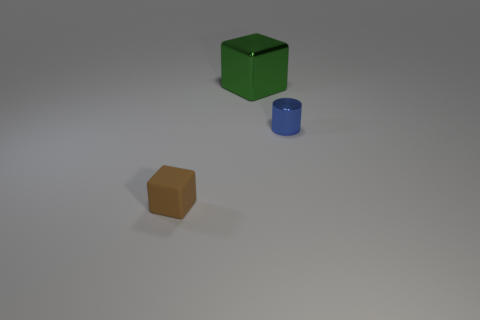Add 3 green matte objects. How many objects exist? 6 Subtract all green cubes. How many cubes are left? 1 Subtract all cylinders. How many objects are left? 2 Subtract all small matte things. Subtract all metal blocks. How many objects are left? 1 Add 2 cylinders. How many cylinders are left? 3 Add 3 gray metallic blocks. How many gray metallic blocks exist? 3 Subtract 0 red cylinders. How many objects are left? 3 Subtract all cyan blocks. Subtract all green cylinders. How many blocks are left? 2 